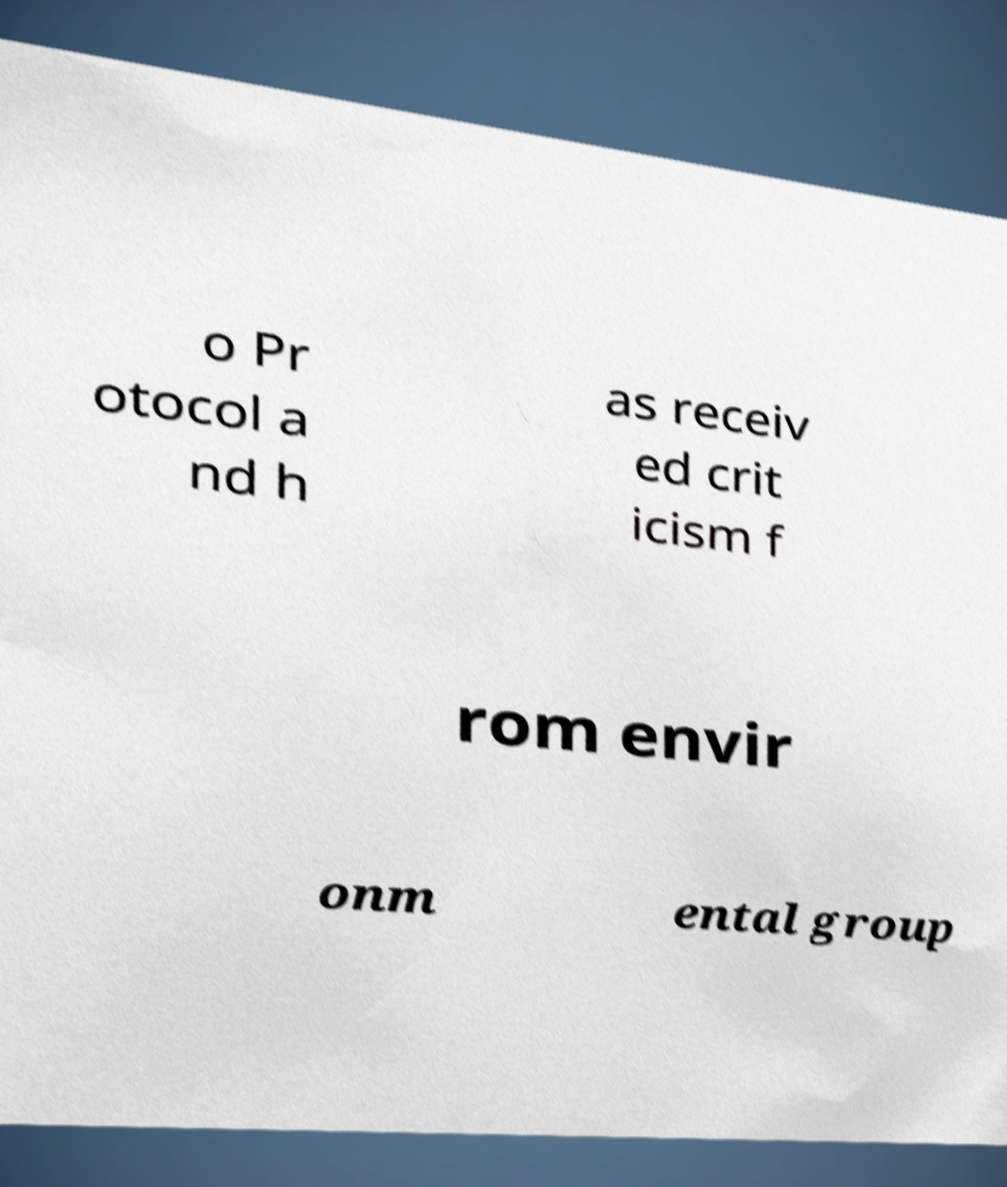There's text embedded in this image that I need extracted. Can you transcribe it verbatim? o Pr otocol a nd h as receiv ed crit icism f rom envir onm ental group 